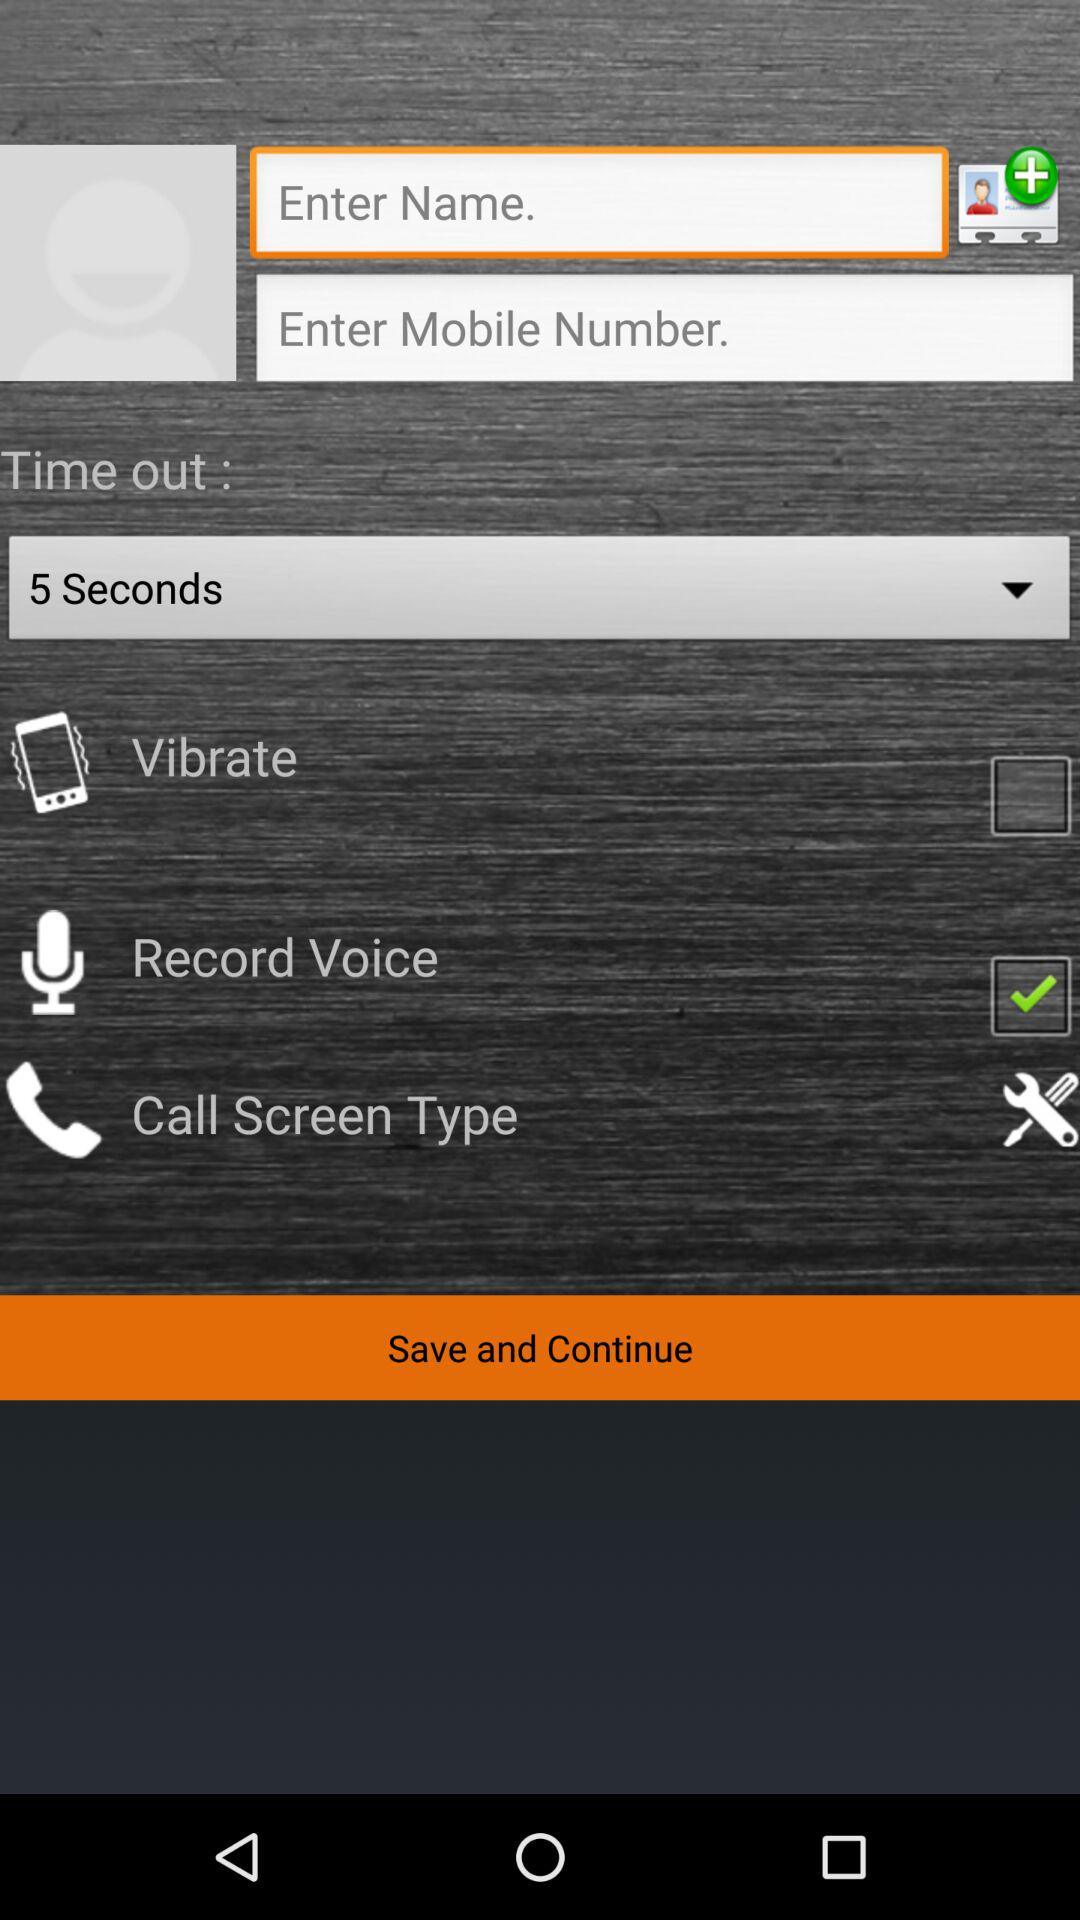What duration is selected for time out? The duration selected for time out is 5 seconds. 